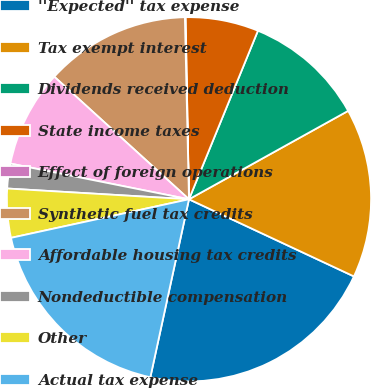Convert chart to OTSL. <chart><loc_0><loc_0><loc_500><loc_500><pie_chart><fcel>''Expected'' tax expense<fcel>Tax exempt interest<fcel>Dividends received deduction<fcel>State income taxes<fcel>Effect of foreign operations<fcel>Synthetic fuel tax credits<fcel>Affordable housing tax credits<fcel>Nondeductible compensation<fcel>Other<fcel>Actual tax expense<nl><fcel>21.44%<fcel>15.03%<fcel>10.75%<fcel>6.48%<fcel>0.06%<fcel>12.89%<fcel>8.61%<fcel>2.2%<fcel>4.34%<fcel>18.2%<nl></chart> 